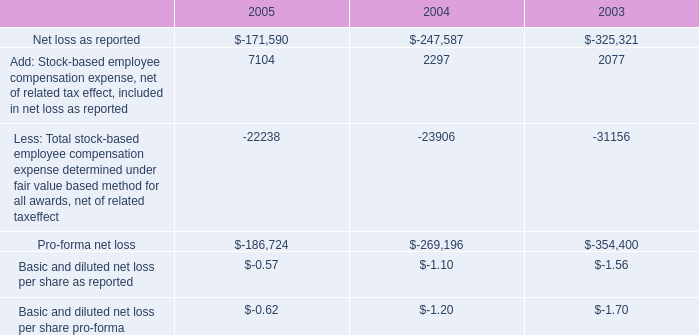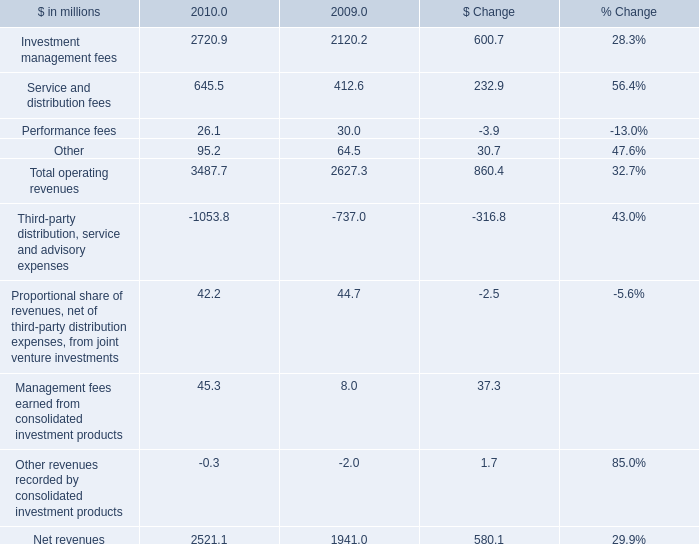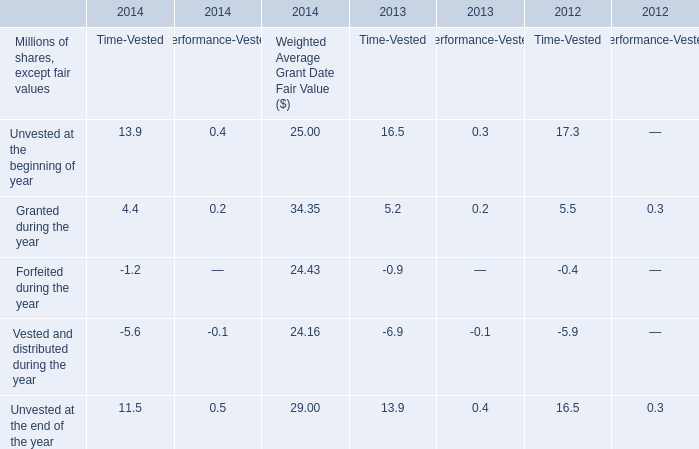What is the growing rate of Third-party distribution, service and advisory expenses in the year with the least Total operating revenues ? 
Computations: ((-1053.8 - 737.0) / -737.0)
Answer: 2.42985. 